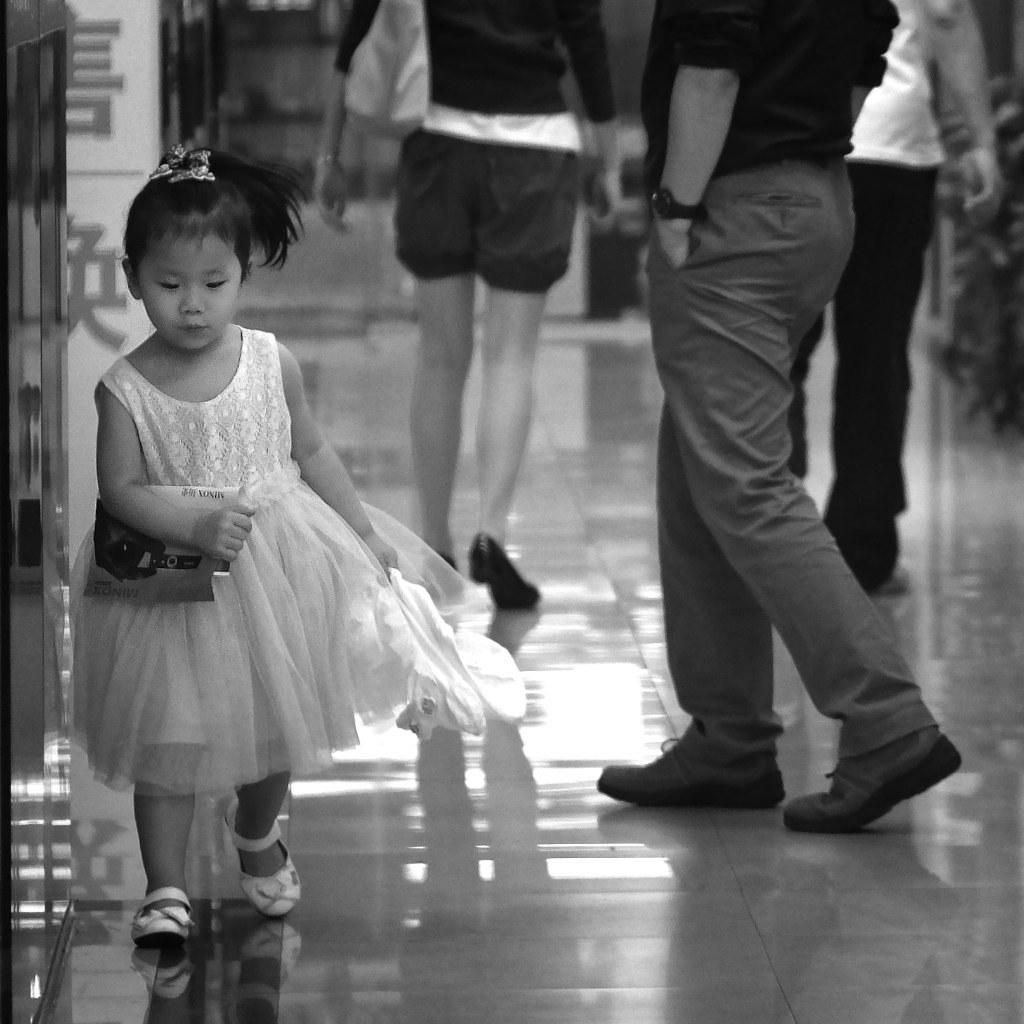What is the main subject of the image? There is a person walking in the image. Can you describe the surroundings of the person? There are other people in the background of the image. What is the color scheme of the image? The image is in black and white. What type of coat is the toy wearing in the image? There is no toy or coat present in the image. 